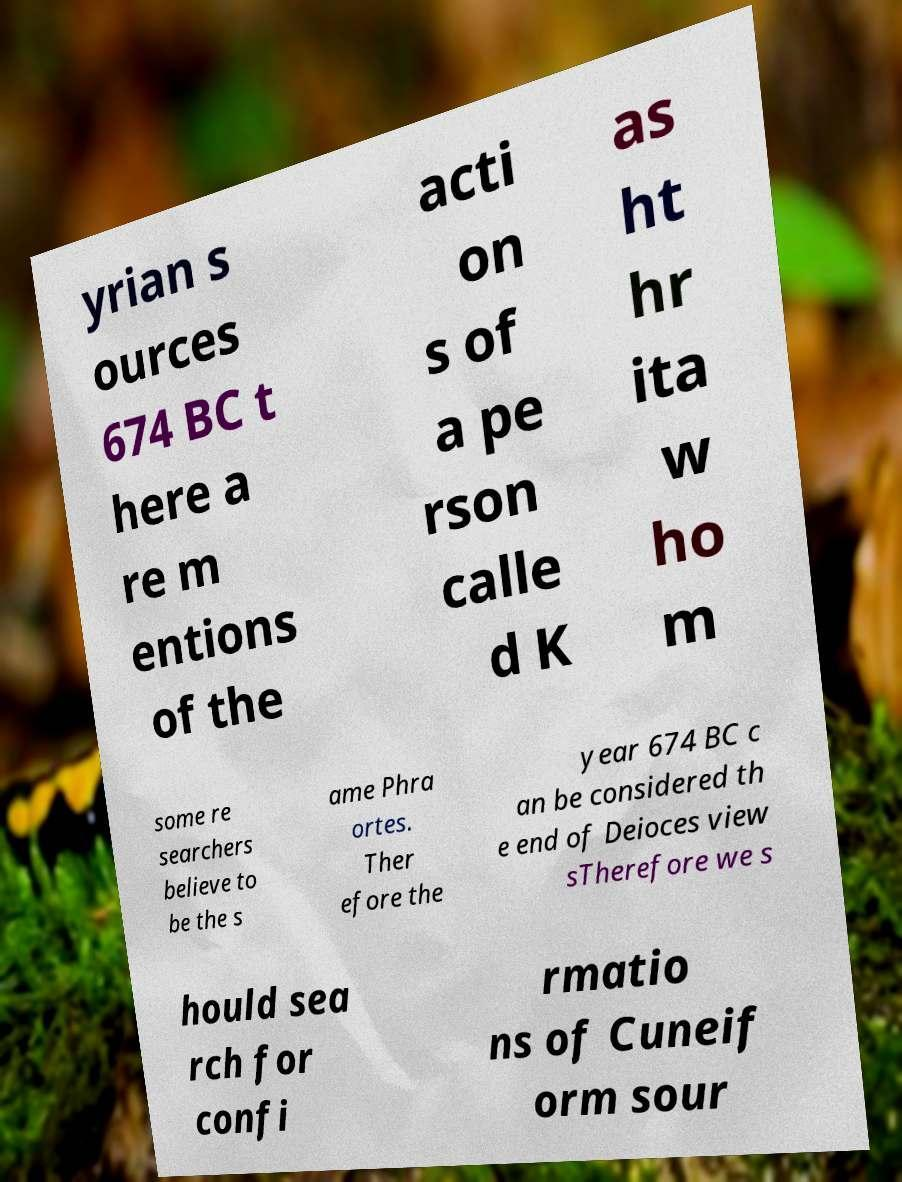Please read and relay the text visible in this image. What does it say? yrian s ources 674 BC t here a re m entions of the acti on s of a pe rson calle d K as ht hr ita w ho m some re searchers believe to be the s ame Phra ortes. Ther efore the year 674 BC c an be considered th e end of Deioces view sTherefore we s hould sea rch for confi rmatio ns of Cuneif orm sour 